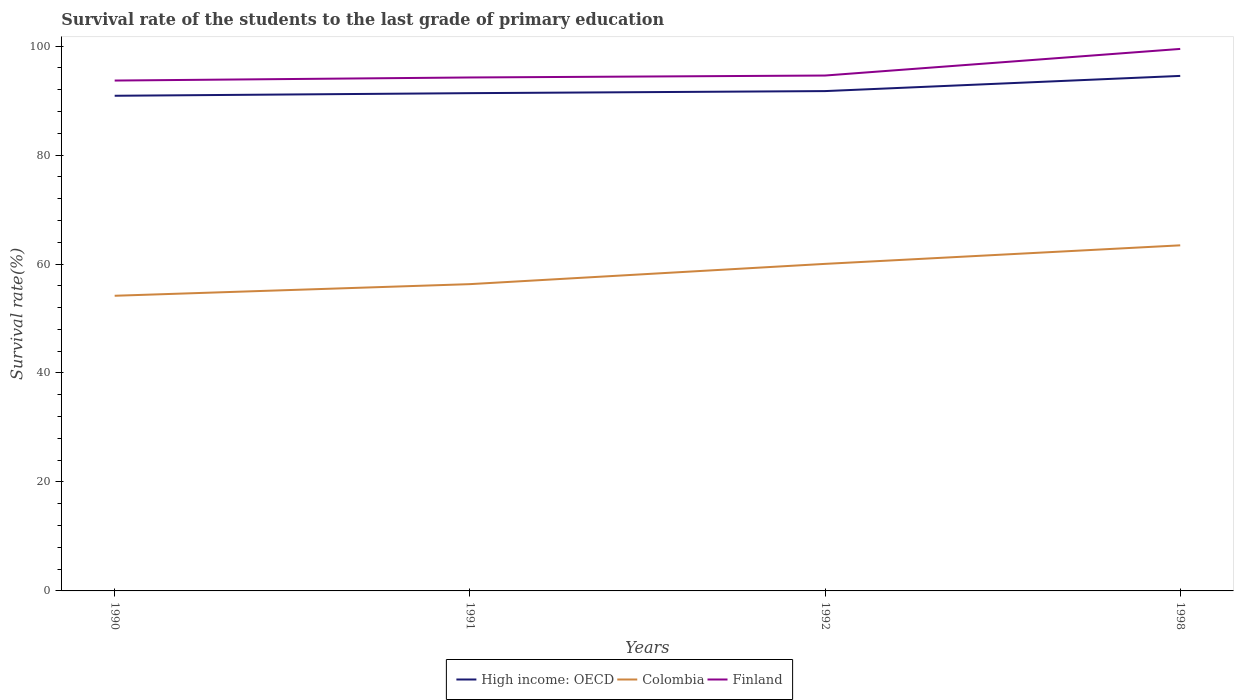Does the line corresponding to Finland intersect with the line corresponding to Colombia?
Your answer should be very brief. No. Is the number of lines equal to the number of legend labels?
Provide a succinct answer. Yes. Across all years, what is the maximum survival rate of the students in High income: OECD?
Provide a short and direct response. 90.89. In which year was the survival rate of the students in High income: OECD maximum?
Your answer should be very brief. 1990. What is the total survival rate of the students in Colombia in the graph?
Give a very brief answer. -3.72. What is the difference between the highest and the second highest survival rate of the students in Finland?
Ensure brevity in your answer.  5.8. What is the difference between the highest and the lowest survival rate of the students in High income: OECD?
Your answer should be very brief. 1. Does the graph contain any zero values?
Your answer should be very brief. No. Does the graph contain grids?
Offer a terse response. No. How are the legend labels stacked?
Make the answer very short. Horizontal. What is the title of the graph?
Ensure brevity in your answer.  Survival rate of the students to the last grade of primary education. What is the label or title of the Y-axis?
Provide a succinct answer. Survival rate(%). What is the Survival rate(%) of High income: OECD in 1990?
Your response must be concise. 90.89. What is the Survival rate(%) in Colombia in 1990?
Keep it short and to the point. 54.18. What is the Survival rate(%) of Finland in 1990?
Make the answer very short. 93.68. What is the Survival rate(%) in High income: OECD in 1991?
Provide a succinct answer. 91.37. What is the Survival rate(%) of Colombia in 1991?
Offer a very short reply. 56.31. What is the Survival rate(%) of Finland in 1991?
Ensure brevity in your answer.  94.24. What is the Survival rate(%) in High income: OECD in 1992?
Ensure brevity in your answer.  91.74. What is the Survival rate(%) of Colombia in 1992?
Provide a succinct answer. 60.03. What is the Survival rate(%) of Finland in 1992?
Provide a short and direct response. 94.6. What is the Survival rate(%) of High income: OECD in 1998?
Provide a succinct answer. 94.53. What is the Survival rate(%) in Colombia in 1998?
Provide a short and direct response. 63.43. What is the Survival rate(%) of Finland in 1998?
Ensure brevity in your answer.  99.48. Across all years, what is the maximum Survival rate(%) in High income: OECD?
Provide a succinct answer. 94.53. Across all years, what is the maximum Survival rate(%) of Colombia?
Provide a succinct answer. 63.43. Across all years, what is the maximum Survival rate(%) of Finland?
Offer a very short reply. 99.48. Across all years, what is the minimum Survival rate(%) of High income: OECD?
Ensure brevity in your answer.  90.89. Across all years, what is the minimum Survival rate(%) of Colombia?
Ensure brevity in your answer.  54.18. Across all years, what is the minimum Survival rate(%) in Finland?
Keep it short and to the point. 93.68. What is the total Survival rate(%) in High income: OECD in the graph?
Provide a short and direct response. 368.53. What is the total Survival rate(%) of Colombia in the graph?
Ensure brevity in your answer.  233.95. What is the total Survival rate(%) in Finland in the graph?
Ensure brevity in your answer.  382.01. What is the difference between the Survival rate(%) of High income: OECD in 1990 and that in 1991?
Offer a terse response. -0.48. What is the difference between the Survival rate(%) of Colombia in 1990 and that in 1991?
Your answer should be compact. -2.13. What is the difference between the Survival rate(%) in Finland in 1990 and that in 1991?
Ensure brevity in your answer.  -0.56. What is the difference between the Survival rate(%) of High income: OECD in 1990 and that in 1992?
Make the answer very short. -0.86. What is the difference between the Survival rate(%) in Colombia in 1990 and that in 1992?
Provide a succinct answer. -5.85. What is the difference between the Survival rate(%) of Finland in 1990 and that in 1992?
Your answer should be compact. -0.92. What is the difference between the Survival rate(%) in High income: OECD in 1990 and that in 1998?
Give a very brief answer. -3.64. What is the difference between the Survival rate(%) of Colombia in 1990 and that in 1998?
Make the answer very short. -9.26. What is the difference between the Survival rate(%) in Finland in 1990 and that in 1998?
Keep it short and to the point. -5.8. What is the difference between the Survival rate(%) in High income: OECD in 1991 and that in 1992?
Make the answer very short. -0.38. What is the difference between the Survival rate(%) in Colombia in 1991 and that in 1992?
Offer a very short reply. -3.72. What is the difference between the Survival rate(%) of Finland in 1991 and that in 1992?
Offer a very short reply. -0.35. What is the difference between the Survival rate(%) of High income: OECD in 1991 and that in 1998?
Provide a short and direct response. -3.16. What is the difference between the Survival rate(%) of Colombia in 1991 and that in 1998?
Give a very brief answer. -7.12. What is the difference between the Survival rate(%) in Finland in 1991 and that in 1998?
Offer a very short reply. -5.24. What is the difference between the Survival rate(%) in High income: OECD in 1992 and that in 1998?
Provide a short and direct response. -2.79. What is the difference between the Survival rate(%) in Colombia in 1992 and that in 1998?
Provide a succinct answer. -3.4. What is the difference between the Survival rate(%) in Finland in 1992 and that in 1998?
Provide a short and direct response. -4.89. What is the difference between the Survival rate(%) in High income: OECD in 1990 and the Survival rate(%) in Colombia in 1991?
Your response must be concise. 34.58. What is the difference between the Survival rate(%) of High income: OECD in 1990 and the Survival rate(%) of Finland in 1991?
Provide a short and direct response. -3.36. What is the difference between the Survival rate(%) in Colombia in 1990 and the Survival rate(%) in Finland in 1991?
Your response must be concise. -40.07. What is the difference between the Survival rate(%) in High income: OECD in 1990 and the Survival rate(%) in Colombia in 1992?
Offer a terse response. 30.86. What is the difference between the Survival rate(%) of High income: OECD in 1990 and the Survival rate(%) of Finland in 1992?
Provide a short and direct response. -3.71. What is the difference between the Survival rate(%) of Colombia in 1990 and the Survival rate(%) of Finland in 1992?
Give a very brief answer. -40.42. What is the difference between the Survival rate(%) of High income: OECD in 1990 and the Survival rate(%) of Colombia in 1998?
Give a very brief answer. 27.45. What is the difference between the Survival rate(%) in High income: OECD in 1990 and the Survival rate(%) in Finland in 1998?
Offer a terse response. -8.6. What is the difference between the Survival rate(%) in Colombia in 1990 and the Survival rate(%) in Finland in 1998?
Offer a very short reply. -45.31. What is the difference between the Survival rate(%) of High income: OECD in 1991 and the Survival rate(%) of Colombia in 1992?
Ensure brevity in your answer.  31.34. What is the difference between the Survival rate(%) in High income: OECD in 1991 and the Survival rate(%) in Finland in 1992?
Provide a succinct answer. -3.23. What is the difference between the Survival rate(%) of Colombia in 1991 and the Survival rate(%) of Finland in 1992?
Your answer should be very brief. -38.29. What is the difference between the Survival rate(%) of High income: OECD in 1991 and the Survival rate(%) of Colombia in 1998?
Make the answer very short. 27.93. What is the difference between the Survival rate(%) of High income: OECD in 1991 and the Survival rate(%) of Finland in 1998?
Your answer should be compact. -8.12. What is the difference between the Survival rate(%) of Colombia in 1991 and the Survival rate(%) of Finland in 1998?
Make the answer very short. -43.17. What is the difference between the Survival rate(%) in High income: OECD in 1992 and the Survival rate(%) in Colombia in 1998?
Keep it short and to the point. 28.31. What is the difference between the Survival rate(%) in High income: OECD in 1992 and the Survival rate(%) in Finland in 1998?
Give a very brief answer. -7.74. What is the difference between the Survival rate(%) of Colombia in 1992 and the Survival rate(%) of Finland in 1998?
Your answer should be compact. -39.45. What is the average Survival rate(%) of High income: OECD per year?
Offer a very short reply. 92.13. What is the average Survival rate(%) in Colombia per year?
Make the answer very short. 58.49. What is the average Survival rate(%) in Finland per year?
Your answer should be compact. 95.5. In the year 1990, what is the difference between the Survival rate(%) of High income: OECD and Survival rate(%) of Colombia?
Offer a very short reply. 36.71. In the year 1990, what is the difference between the Survival rate(%) of High income: OECD and Survival rate(%) of Finland?
Your response must be concise. -2.79. In the year 1990, what is the difference between the Survival rate(%) in Colombia and Survival rate(%) in Finland?
Your response must be concise. -39.5. In the year 1991, what is the difference between the Survival rate(%) in High income: OECD and Survival rate(%) in Colombia?
Provide a short and direct response. 35.06. In the year 1991, what is the difference between the Survival rate(%) of High income: OECD and Survival rate(%) of Finland?
Your answer should be compact. -2.88. In the year 1991, what is the difference between the Survival rate(%) of Colombia and Survival rate(%) of Finland?
Keep it short and to the point. -37.93. In the year 1992, what is the difference between the Survival rate(%) of High income: OECD and Survival rate(%) of Colombia?
Ensure brevity in your answer.  31.71. In the year 1992, what is the difference between the Survival rate(%) of High income: OECD and Survival rate(%) of Finland?
Offer a terse response. -2.86. In the year 1992, what is the difference between the Survival rate(%) of Colombia and Survival rate(%) of Finland?
Offer a very short reply. -34.57. In the year 1998, what is the difference between the Survival rate(%) in High income: OECD and Survival rate(%) in Colombia?
Your answer should be compact. 31.1. In the year 1998, what is the difference between the Survival rate(%) in High income: OECD and Survival rate(%) in Finland?
Keep it short and to the point. -4.96. In the year 1998, what is the difference between the Survival rate(%) in Colombia and Survival rate(%) in Finland?
Provide a succinct answer. -36.05. What is the ratio of the Survival rate(%) of Colombia in 1990 to that in 1991?
Your answer should be compact. 0.96. What is the ratio of the Survival rate(%) in Finland in 1990 to that in 1991?
Provide a succinct answer. 0.99. What is the ratio of the Survival rate(%) of High income: OECD in 1990 to that in 1992?
Ensure brevity in your answer.  0.99. What is the ratio of the Survival rate(%) in Colombia in 1990 to that in 1992?
Offer a terse response. 0.9. What is the ratio of the Survival rate(%) in Finland in 1990 to that in 1992?
Give a very brief answer. 0.99. What is the ratio of the Survival rate(%) in High income: OECD in 1990 to that in 1998?
Your answer should be very brief. 0.96. What is the ratio of the Survival rate(%) in Colombia in 1990 to that in 1998?
Provide a short and direct response. 0.85. What is the ratio of the Survival rate(%) of Finland in 1990 to that in 1998?
Give a very brief answer. 0.94. What is the ratio of the Survival rate(%) of Colombia in 1991 to that in 1992?
Provide a short and direct response. 0.94. What is the ratio of the Survival rate(%) in High income: OECD in 1991 to that in 1998?
Provide a short and direct response. 0.97. What is the ratio of the Survival rate(%) in Colombia in 1991 to that in 1998?
Keep it short and to the point. 0.89. What is the ratio of the Survival rate(%) in Finland in 1991 to that in 1998?
Offer a very short reply. 0.95. What is the ratio of the Survival rate(%) of High income: OECD in 1992 to that in 1998?
Your answer should be very brief. 0.97. What is the ratio of the Survival rate(%) of Colombia in 1992 to that in 1998?
Offer a very short reply. 0.95. What is the ratio of the Survival rate(%) in Finland in 1992 to that in 1998?
Offer a terse response. 0.95. What is the difference between the highest and the second highest Survival rate(%) of High income: OECD?
Your response must be concise. 2.79. What is the difference between the highest and the second highest Survival rate(%) of Colombia?
Offer a terse response. 3.4. What is the difference between the highest and the second highest Survival rate(%) of Finland?
Provide a short and direct response. 4.89. What is the difference between the highest and the lowest Survival rate(%) in High income: OECD?
Provide a short and direct response. 3.64. What is the difference between the highest and the lowest Survival rate(%) of Colombia?
Provide a short and direct response. 9.26. What is the difference between the highest and the lowest Survival rate(%) of Finland?
Give a very brief answer. 5.8. 